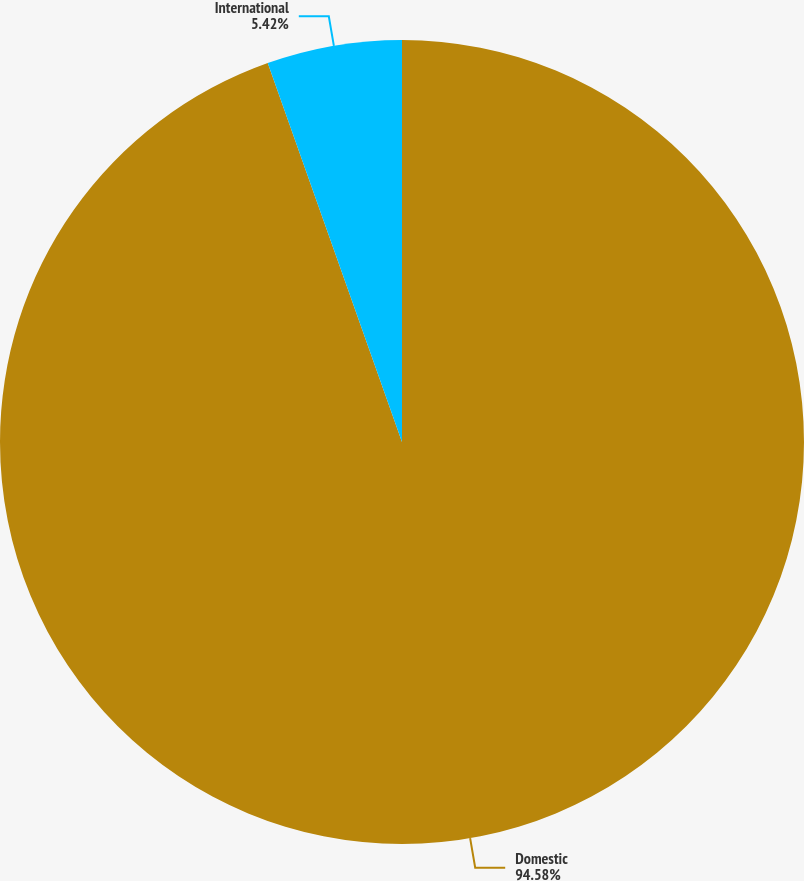Convert chart. <chart><loc_0><loc_0><loc_500><loc_500><pie_chart><fcel>Domestic<fcel>International<nl><fcel>94.58%<fcel>5.42%<nl></chart> 